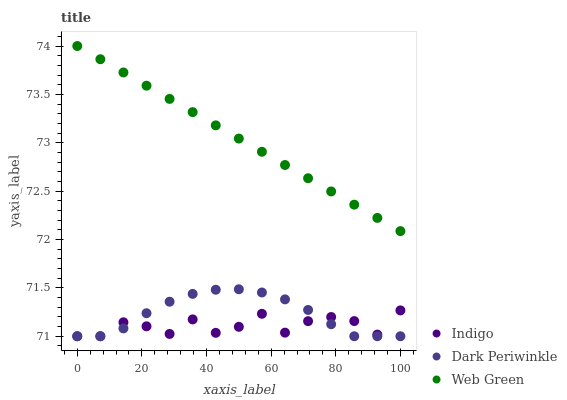Does Indigo have the minimum area under the curve?
Answer yes or no. Yes. Does Web Green have the maximum area under the curve?
Answer yes or no. Yes. Does Dark Periwinkle have the minimum area under the curve?
Answer yes or no. No. Does Dark Periwinkle have the maximum area under the curve?
Answer yes or no. No. Is Web Green the smoothest?
Answer yes or no. Yes. Is Indigo the roughest?
Answer yes or no. Yes. Is Dark Periwinkle the smoothest?
Answer yes or no. No. Is Dark Periwinkle the roughest?
Answer yes or no. No. Does Indigo have the lowest value?
Answer yes or no. Yes. Does Web Green have the lowest value?
Answer yes or no. No. Does Web Green have the highest value?
Answer yes or no. Yes. Does Dark Periwinkle have the highest value?
Answer yes or no. No. Is Indigo less than Web Green?
Answer yes or no. Yes. Is Web Green greater than Dark Periwinkle?
Answer yes or no. Yes. Does Indigo intersect Dark Periwinkle?
Answer yes or no. Yes. Is Indigo less than Dark Periwinkle?
Answer yes or no. No. Is Indigo greater than Dark Periwinkle?
Answer yes or no. No. Does Indigo intersect Web Green?
Answer yes or no. No. 